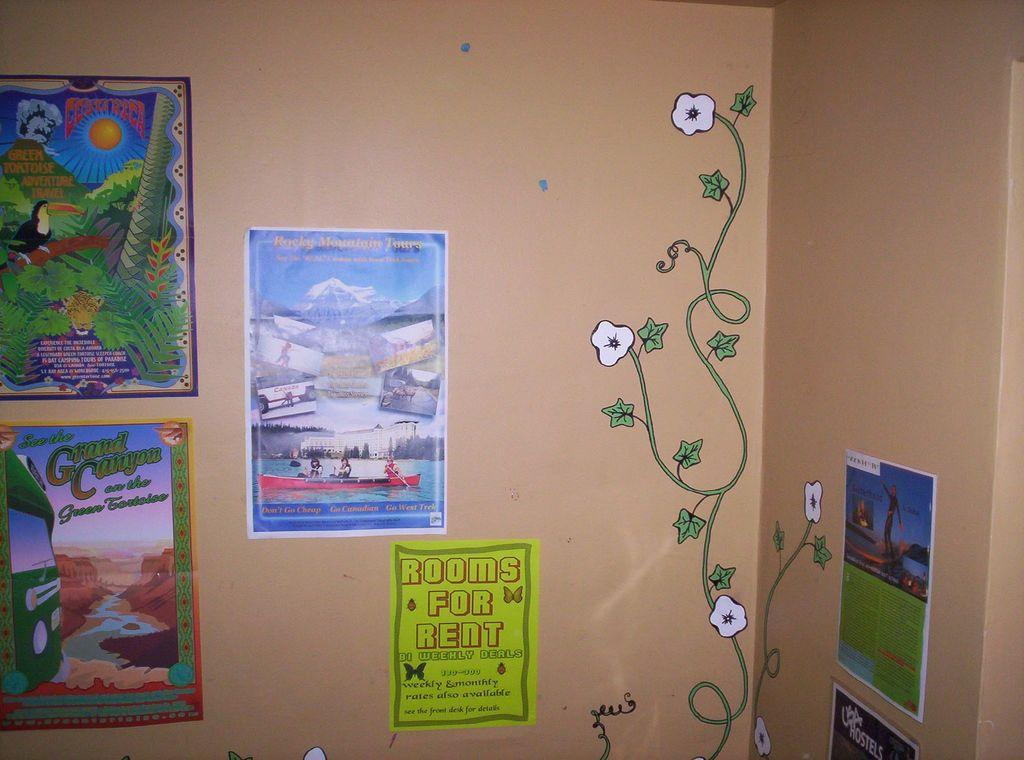Where was the image taken? The image was taken in a room. What can be seen in the front of the image? There is a wall in the front of the image. What is on the wall? There are multiple posters pasted on the wall and a drawing. What type of truck is parked in front of the wall in the image? There is no truck present in the image; it is taken inside a room with a wall and posters. 